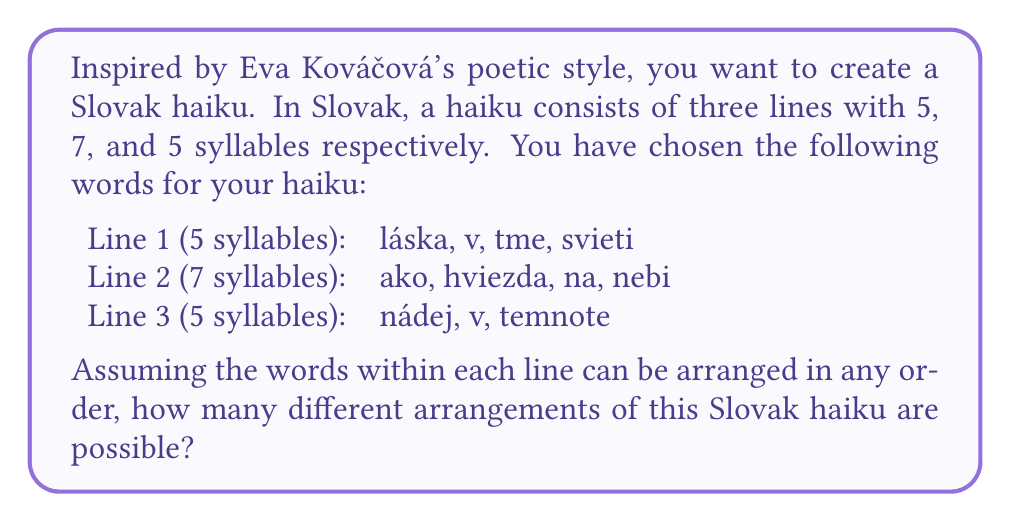Provide a solution to this math problem. To solve this problem, we need to calculate the number of permutations for each line separately and then multiply them together. Let's break it down step by step:

1. For Line 1:
   There are 4 words that can be arranged in any order.
   Number of permutations = $4! = 4 \times 3 \times 2 \times 1 = 24$

2. For Line 2:
   There are 4 words that can be arranged in any order.
   Number of permutations = $4! = 4 \times 3 \times 2 \times 1 = 24$

3. For Line 3:
   There are 3 words that can be arranged in any order.
   Number of permutations = $3! = 3 \times 2 \times 1 = 6$

Now, to find the total number of possible arrangements for the entire haiku, we multiply the number of permutations for each line:

$$\text{Total arrangements} = 24 \times 24 \times 6 = 3,456$$

This is because for each arrangement of Line 1 (24 possibilities), we can have any arrangement of Line 2 (24 possibilities), and for each of these combinations, we can have any arrangement of Line 3 (6 possibilities).
Answer: The total number of possible arrangements for this Slovak haiku is 3,456. 